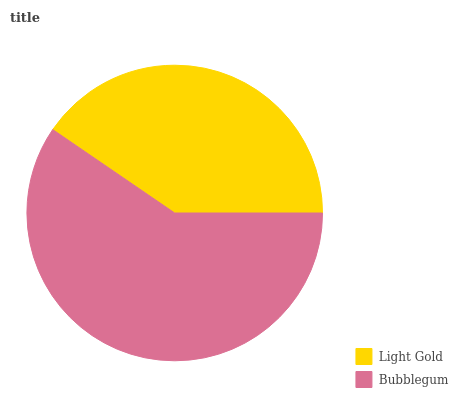Is Light Gold the minimum?
Answer yes or no. Yes. Is Bubblegum the maximum?
Answer yes or no. Yes. Is Bubblegum the minimum?
Answer yes or no. No. Is Bubblegum greater than Light Gold?
Answer yes or no. Yes. Is Light Gold less than Bubblegum?
Answer yes or no. Yes. Is Light Gold greater than Bubblegum?
Answer yes or no. No. Is Bubblegum less than Light Gold?
Answer yes or no. No. Is Bubblegum the high median?
Answer yes or no. Yes. Is Light Gold the low median?
Answer yes or no. Yes. Is Light Gold the high median?
Answer yes or no. No. Is Bubblegum the low median?
Answer yes or no. No. 